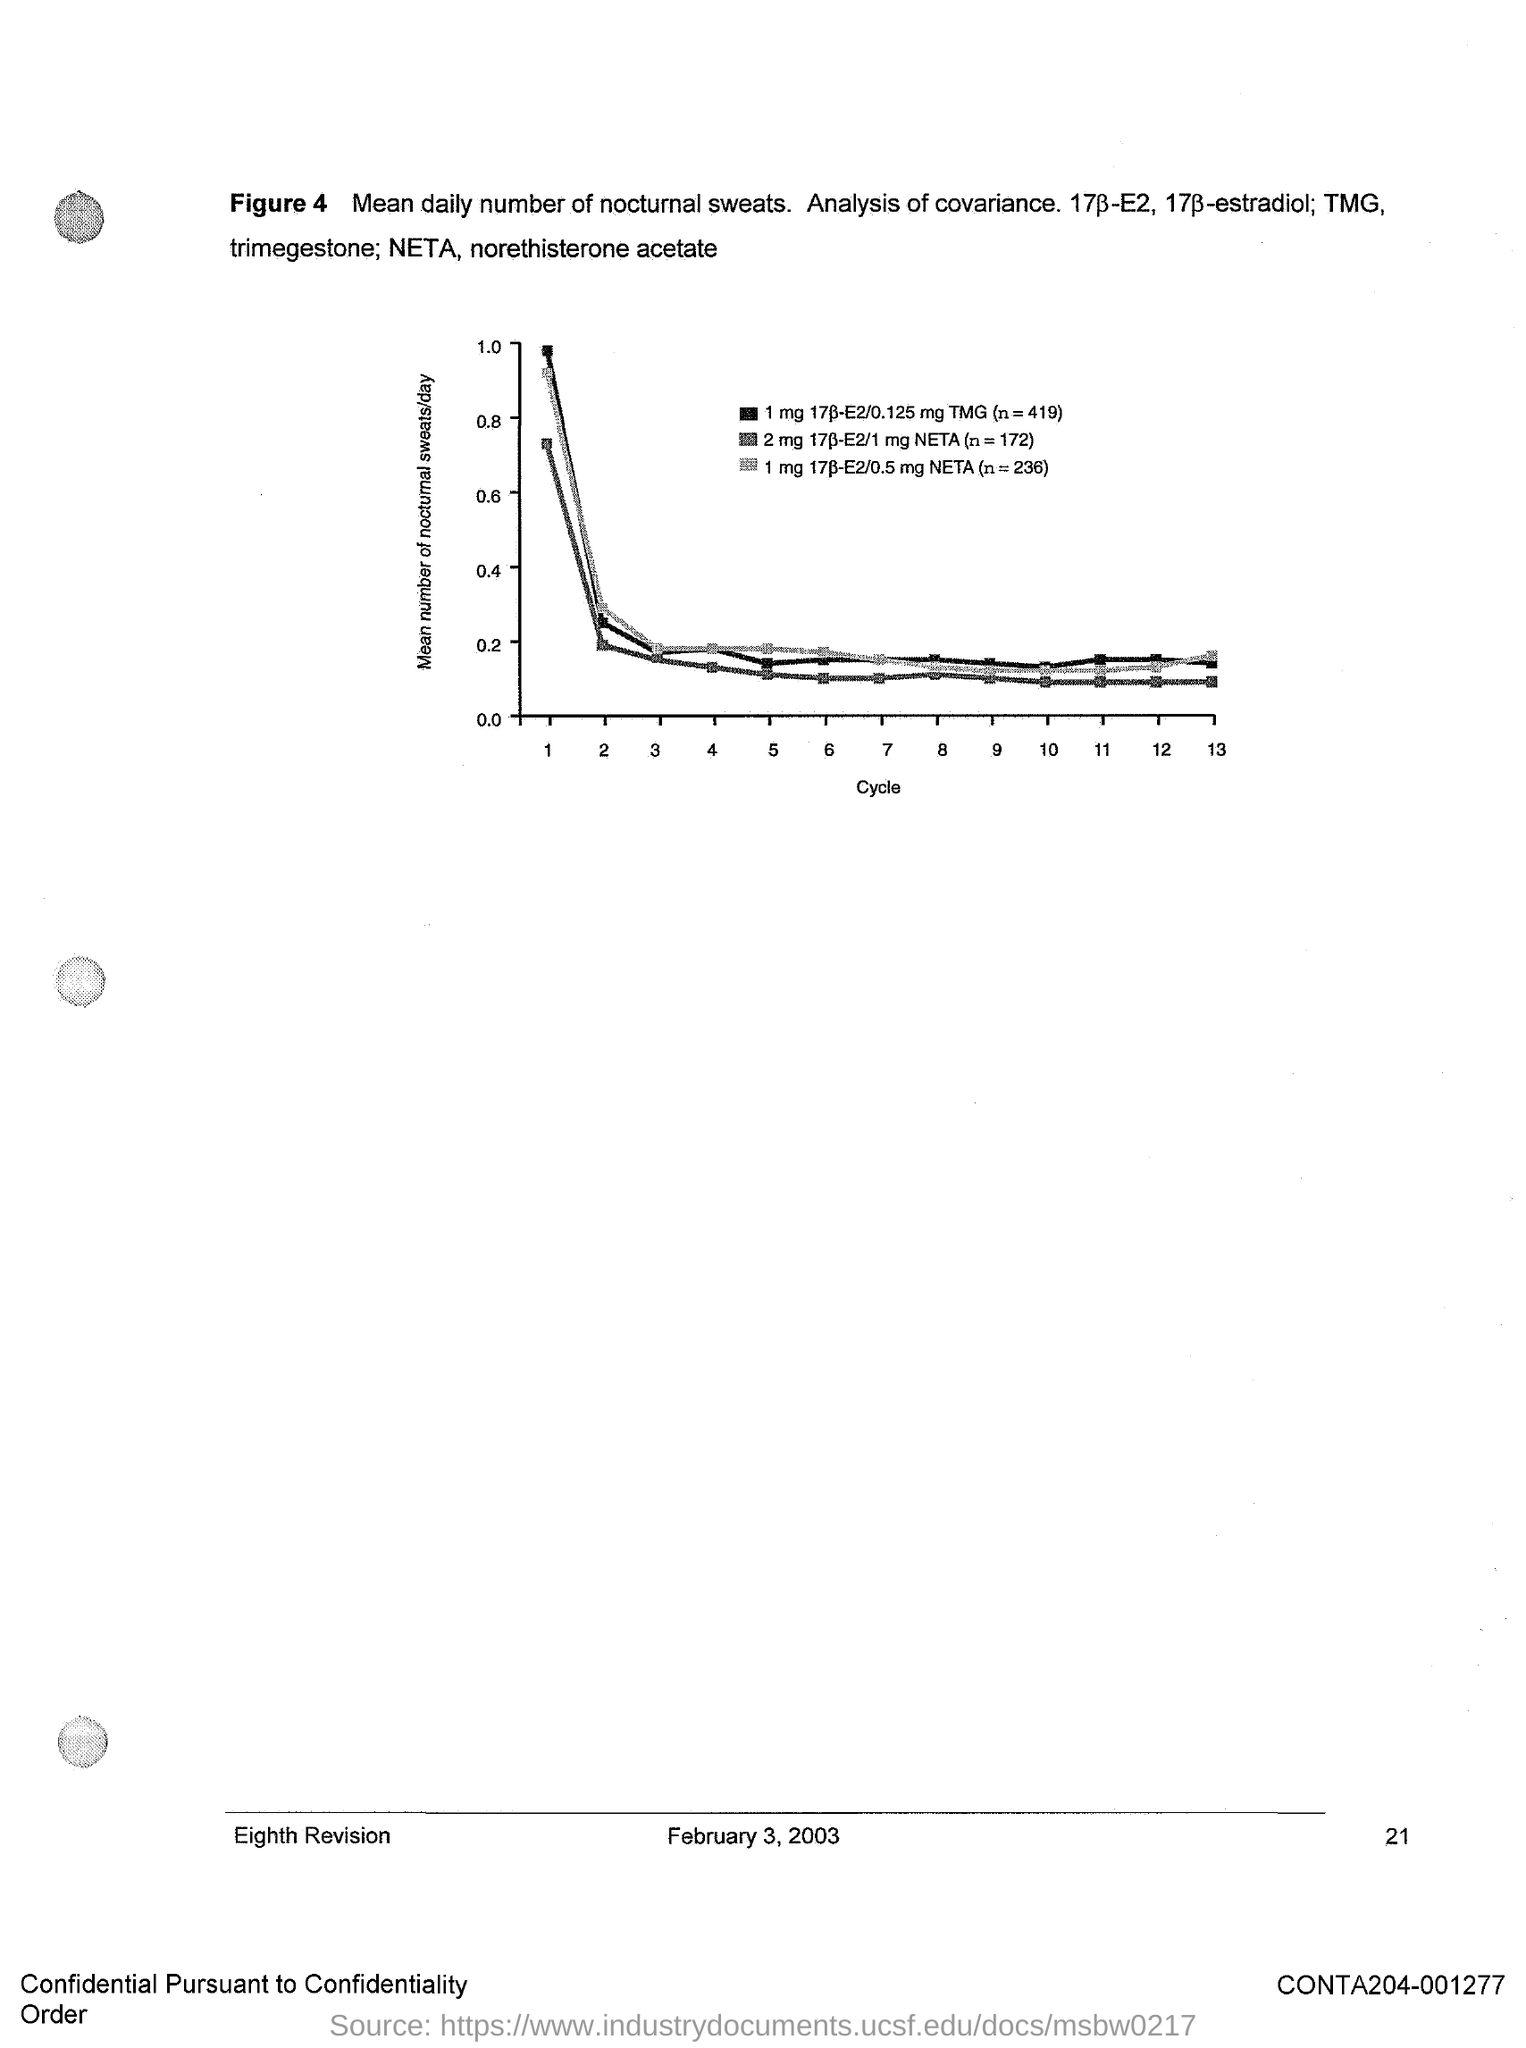Outline some significant characteristics in this image. The document indicates that the date is February 3, 2003. 